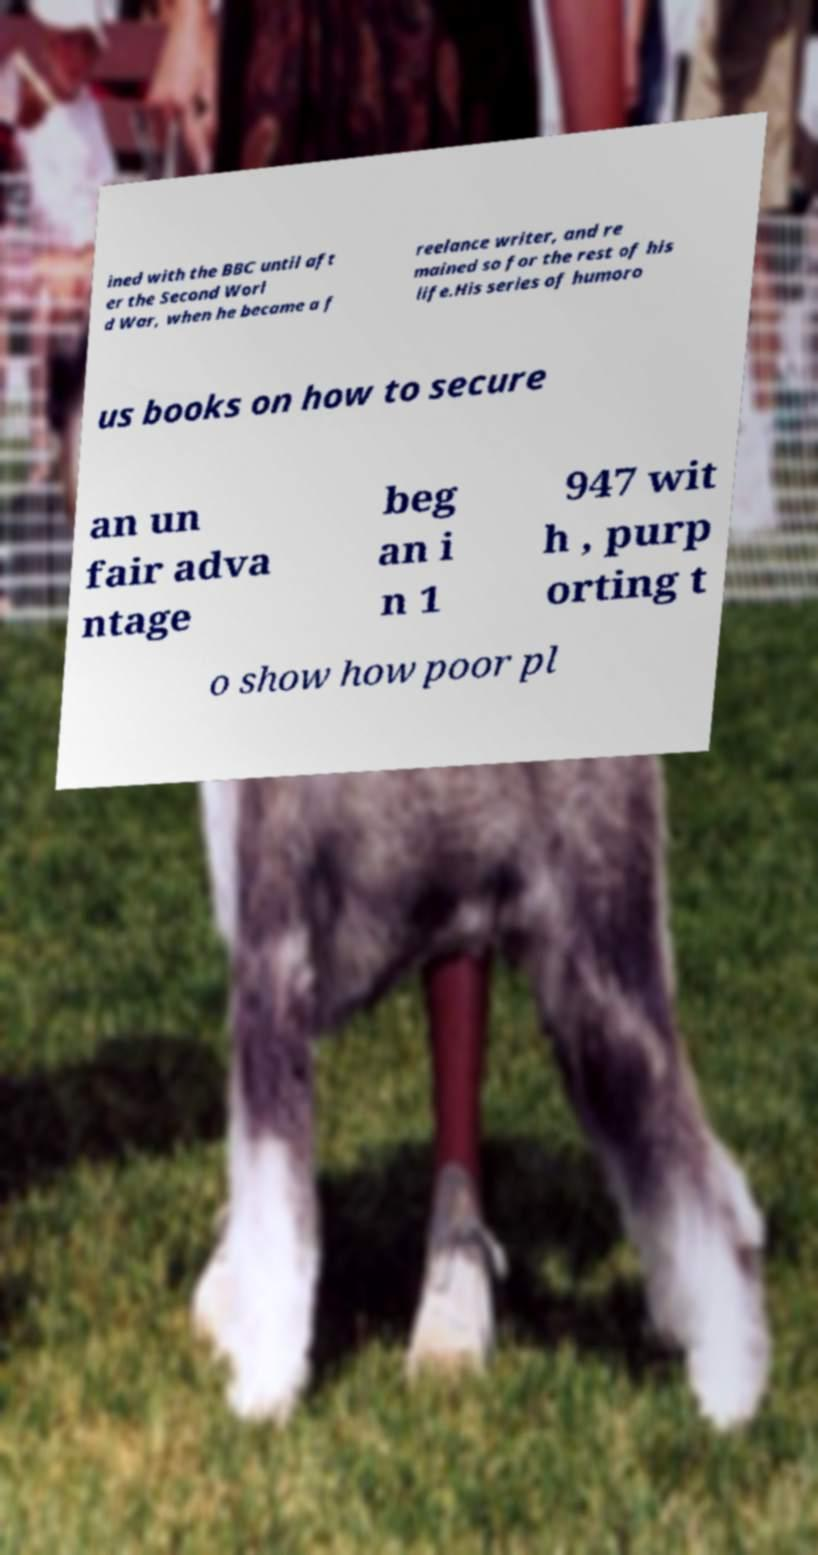For documentation purposes, I need the text within this image transcribed. Could you provide that? ined with the BBC until aft er the Second Worl d War, when he became a f reelance writer, and re mained so for the rest of his life.His series of humoro us books on how to secure an un fair adva ntage beg an i n 1 947 wit h , purp orting t o show how poor pl 